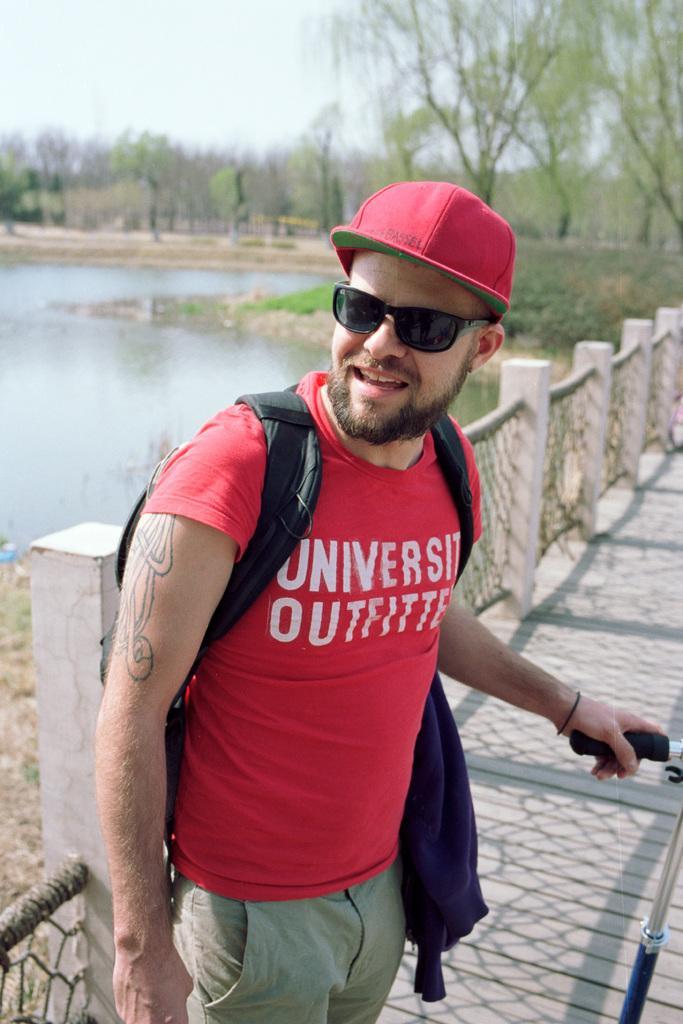Could you give a brief overview of what you see in this image? This is an outside view. Here I can see a man wearing a bag, cap on the head, goggles and smiling by looking at the left side. This person is standing on the floor and holding an object in the hand which seems to be a bird scooter. At the back of this man there is a railing. In the background there is a sea and many trees. At the top of the image I can see the sky. 